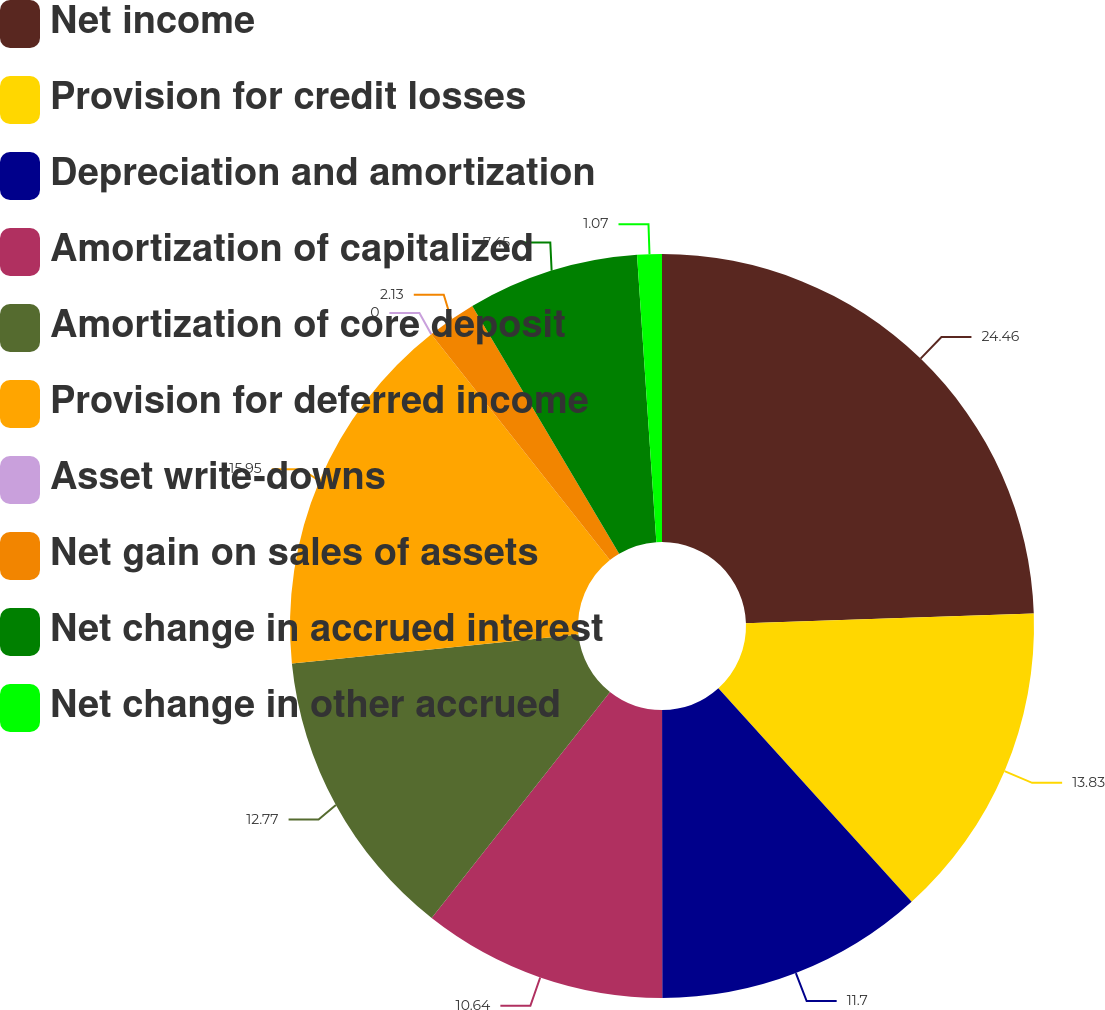Convert chart to OTSL. <chart><loc_0><loc_0><loc_500><loc_500><pie_chart><fcel>Net income<fcel>Provision for credit losses<fcel>Depreciation and amortization<fcel>Amortization of capitalized<fcel>Amortization of core deposit<fcel>Provision for deferred income<fcel>Asset write-downs<fcel>Net gain on sales of assets<fcel>Net change in accrued interest<fcel>Net change in other accrued<nl><fcel>24.47%<fcel>13.83%<fcel>11.7%<fcel>10.64%<fcel>12.77%<fcel>15.96%<fcel>0.0%<fcel>2.13%<fcel>7.45%<fcel>1.07%<nl></chart> 